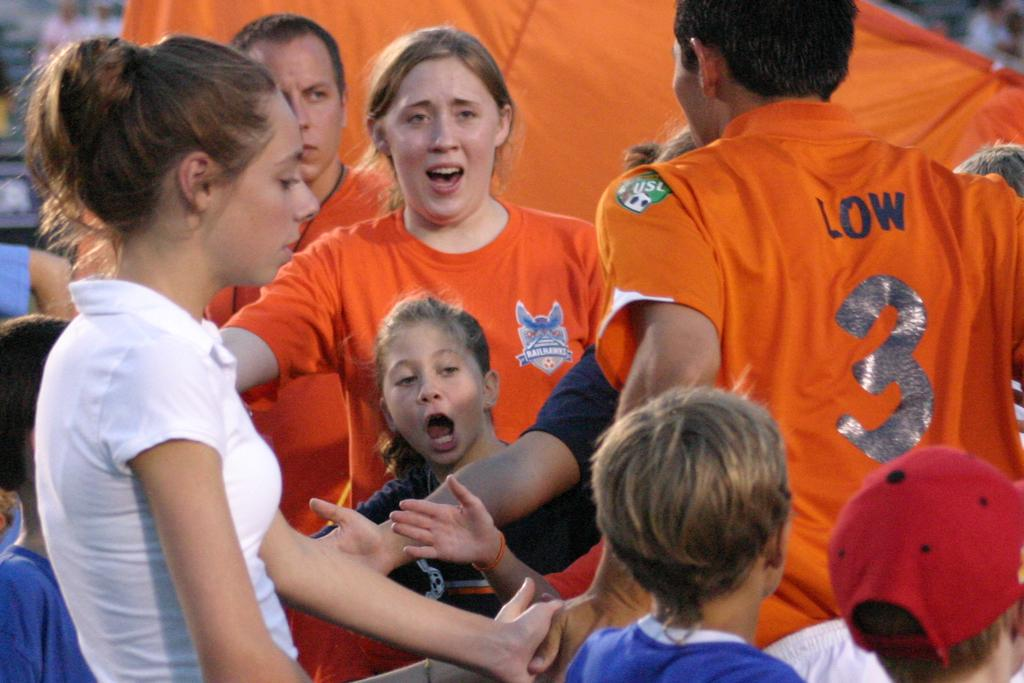<image>
Summarize the visual content of the image. small group of young people including low in number 3 shirt 